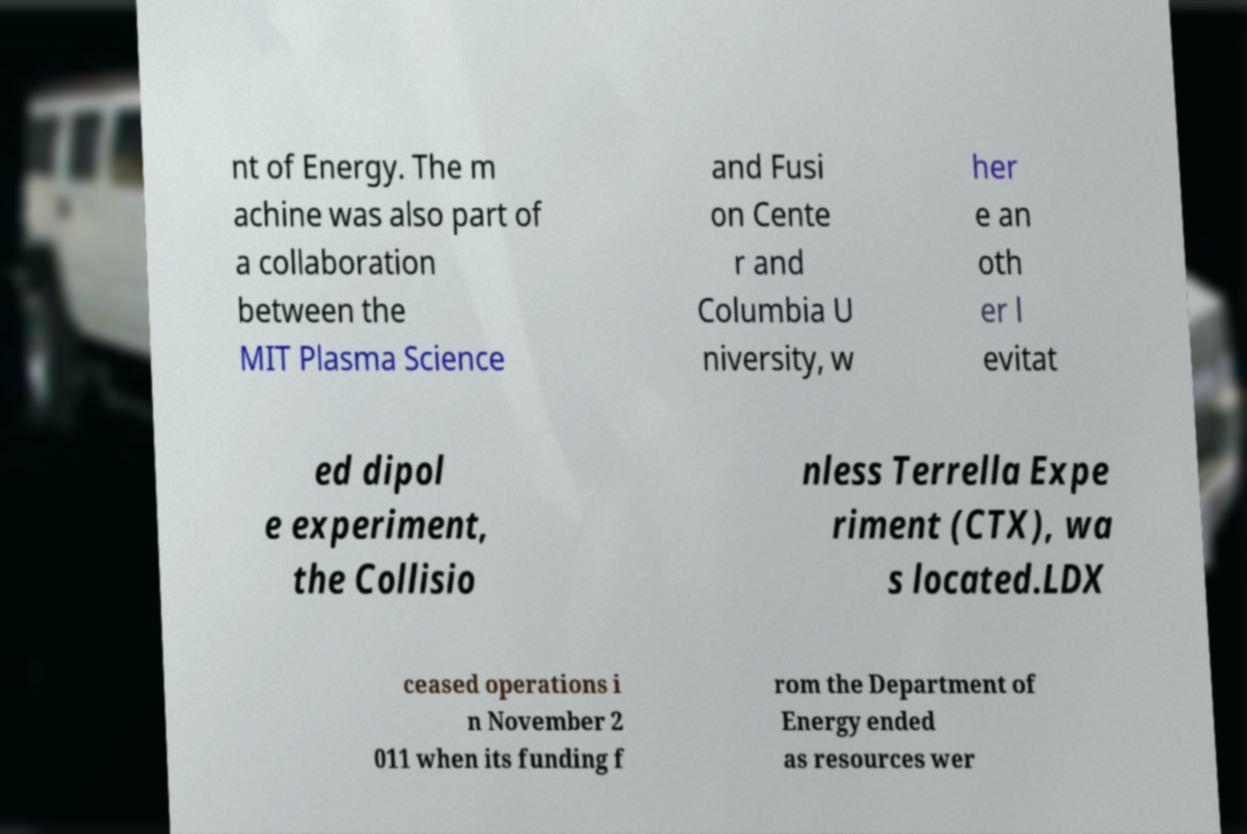I need the written content from this picture converted into text. Can you do that? nt of Energy. The m achine was also part of a collaboration between the MIT Plasma Science and Fusi on Cente r and Columbia U niversity, w her e an oth er l evitat ed dipol e experiment, the Collisio nless Terrella Expe riment (CTX), wa s located.LDX ceased operations i n November 2 011 when its funding f rom the Department of Energy ended as resources wer 